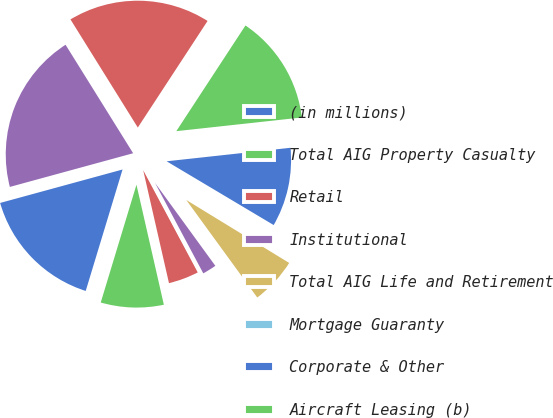Convert chart. <chart><loc_0><loc_0><loc_500><loc_500><pie_chart><fcel>(in millions)<fcel>Total AIG Property Casualty<fcel>Retail<fcel>Institutional<fcel>Total AIG Life and Retirement<fcel>Mortgage Guaranty<fcel>Corporate & Other<fcel>Aircraft Leasing (b)<fcel>Total Other Operations<fcel>Total Assets<nl><fcel>16.07%<fcel>8.26%<fcel>4.23%<fcel>2.21%<fcel>6.25%<fcel>0.19%<fcel>10.28%<fcel>14.05%<fcel>18.09%<fcel>20.38%<nl></chart> 